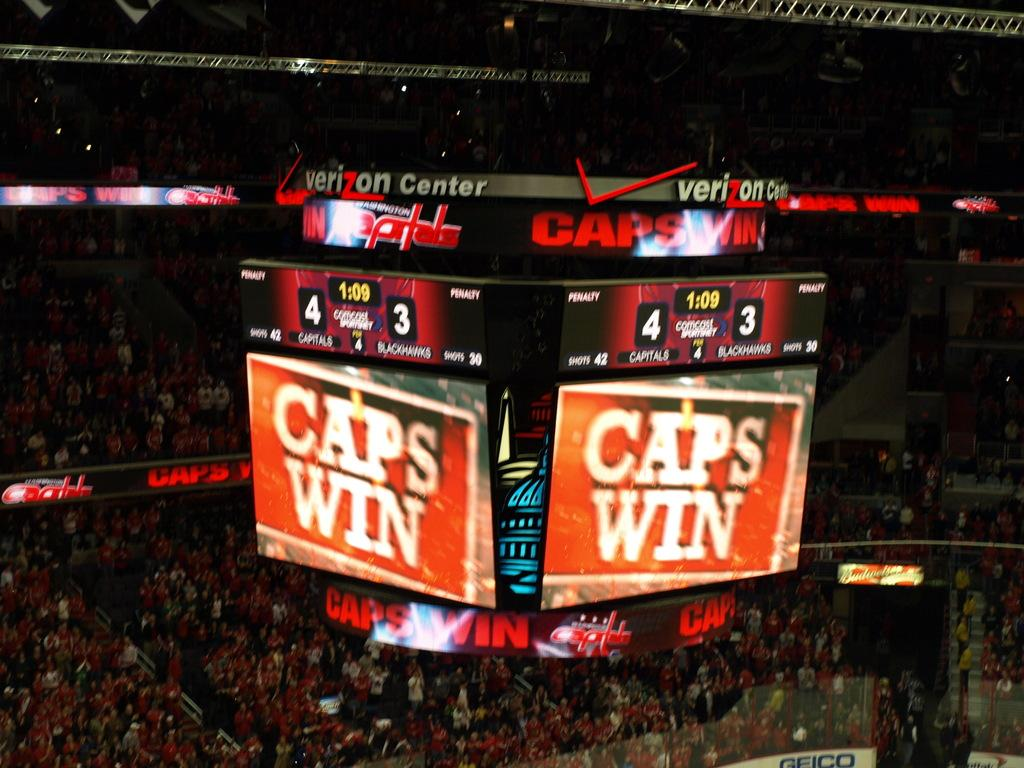<image>
Describe the image concisely. Verizon Center scoreboard for the Capitals and the Blackhawks. 